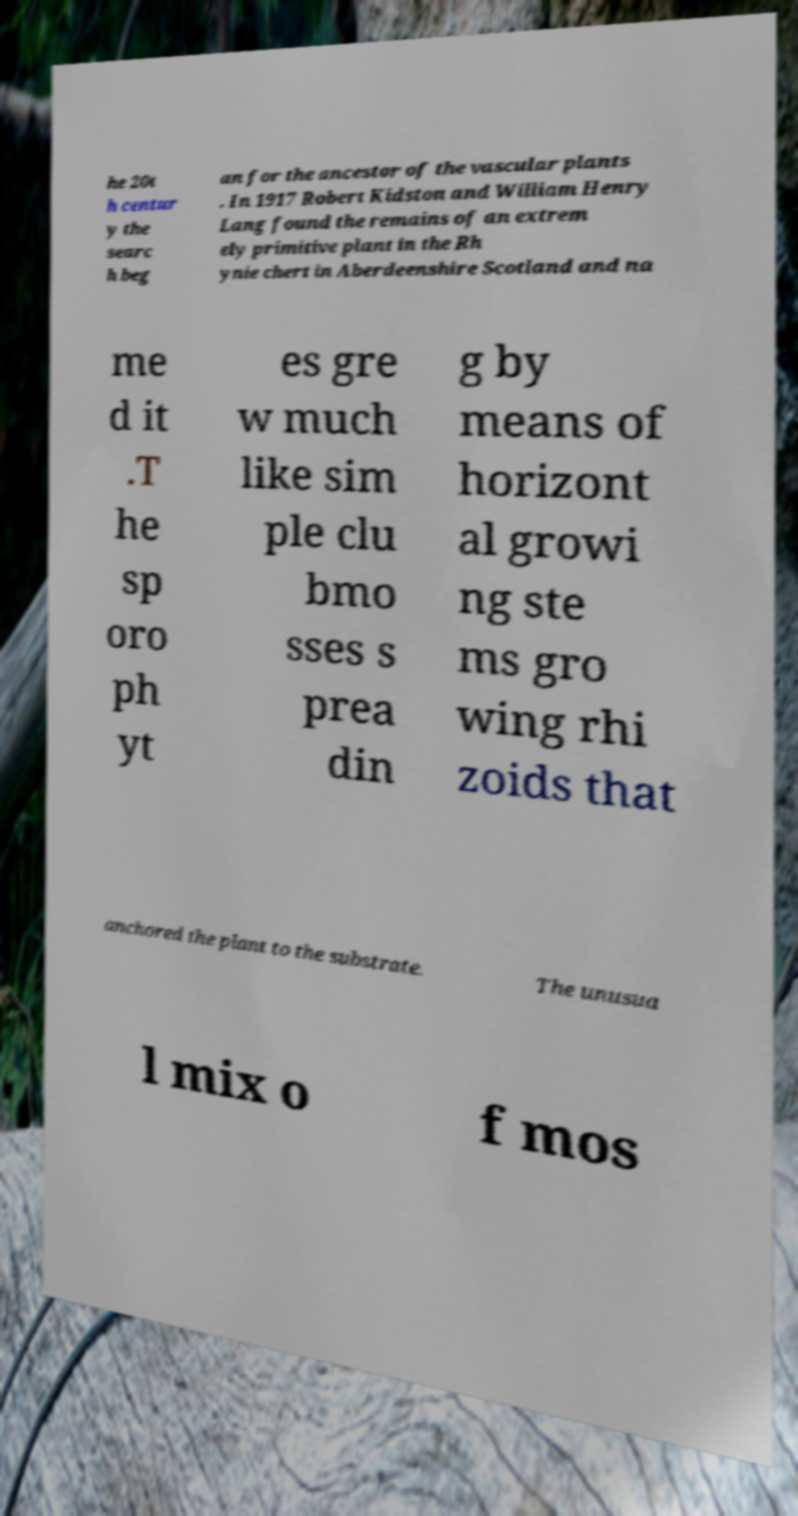Please identify and transcribe the text found in this image. he 20t h centur y the searc h beg an for the ancestor of the vascular plants . In 1917 Robert Kidston and William Henry Lang found the remains of an extrem ely primitive plant in the Rh ynie chert in Aberdeenshire Scotland and na me d it .T he sp oro ph yt es gre w much like sim ple clu bmo sses s prea din g by means of horizont al growi ng ste ms gro wing rhi zoids that anchored the plant to the substrate. The unusua l mix o f mos 